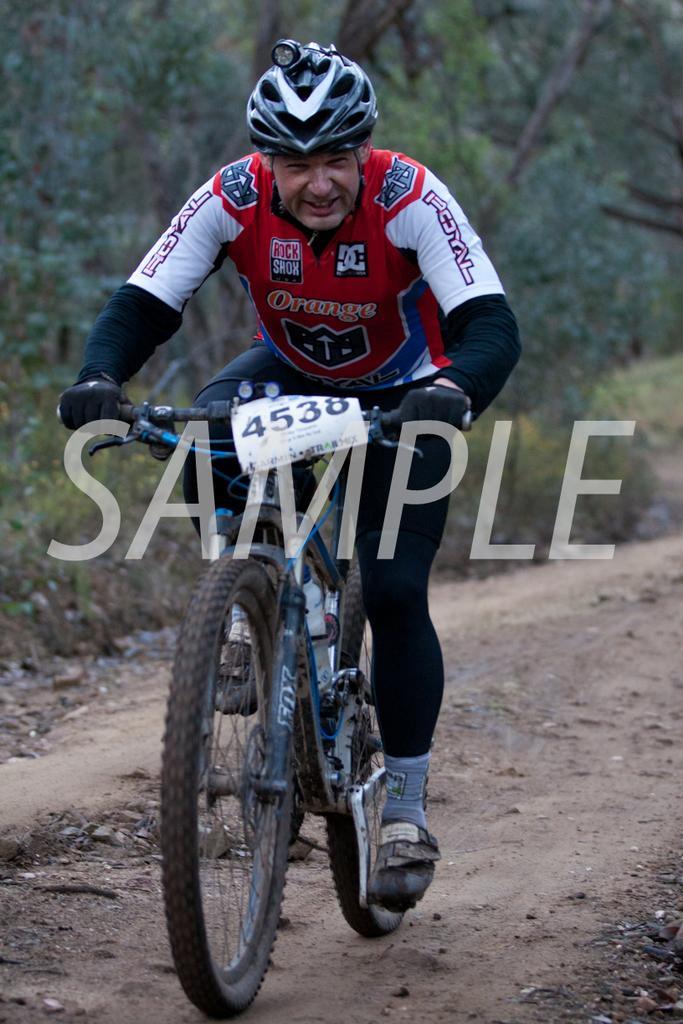Please provide a concise description of this image. In this picture I can see a man is sitting on the bicycle. The man is wearing helmet. In the background I can see trees, plants and road. 